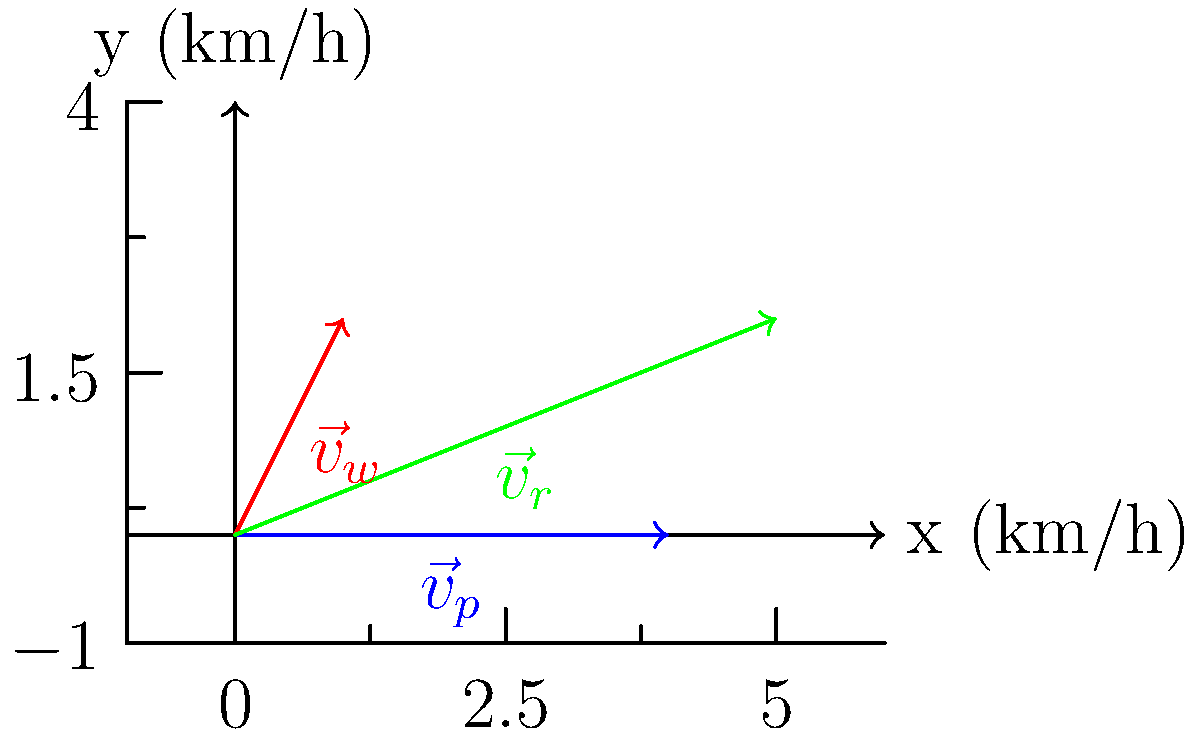During a test flight, your aircraft is traveling east at 400 km/h. You encounter a wind blowing from the south at 200 km/h. Calculate the magnitude of the resultant velocity vector $\vec{v}_r$ and the angle it makes with the positive x-axis (east). Let's approach this step-by-step:

1) First, let's define our vectors:
   $\vec{v}_p = (400, 0)$ km/h (plane velocity)
   $\vec{v}_w = (0, 200)$ km/h (wind velocity)

2) The resultant velocity vector $\vec{v}_r$ is the sum of these two vectors:
   $\vec{v}_r = \vec{v}_p + \vec{v}_w = (400, 0) + (0, 200) = (400, 200)$ km/h

3) To find the magnitude of $\vec{v}_r$, we use the Pythagorean theorem:
   $|\vec{v}_r| = \sqrt{400^2 + 200^2} = \sqrt{160000 + 40000} = \sqrt{200000} = 100\sqrt{20} \approx 447.21$ km/h

4) To find the angle $\theta$ with the positive x-axis, we use the arctangent function:
   $\theta = \tan^{-1}(\frac{200}{400}) = \tan^{-1}(0.5) \approx 26.57°$

Therefore, the resultant velocity vector has a magnitude of approximately 447.21 km/h and makes an angle of about 26.57° with the positive x-axis (east).
Answer: $|\vec{v}_r| \approx 447.21$ km/h, $\theta \approx 26.57°$ 